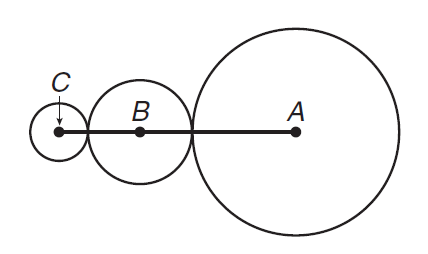Question: G R I D I N In the figure, the radius of circle A is twice the radius of circle B and four times the radius of circle C. If the sum of the circumferences of the three circles is 42 \pi, find the measure of A C.
Choices:
A. 16
B. 18
C. 27
D. 42
Answer with the letter. Answer: C 